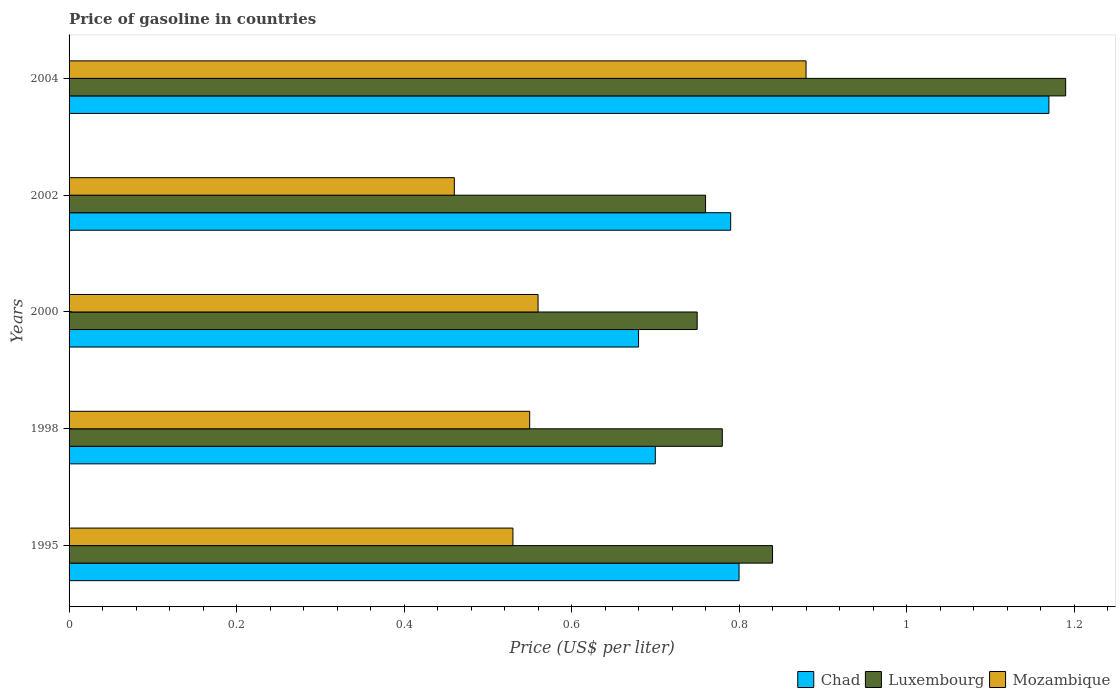Are the number of bars per tick equal to the number of legend labels?
Your response must be concise. Yes. Are the number of bars on each tick of the Y-axis equal?
Provide a succinct answer. Yes. How many bars are there on the 4th tick from the top?
Ensure brevity in your answer.  3. What is the label of the 3rd group of bars from the top?
Your response must be concise. 2000. In how many cases, is the number of bars for a given year not equal to the number of legend labels?
Keep it short and to the point. 0. Across all years, what is the maximum price of gasoline in Luxembourg?
Your answer should be compact. 1.19. Across all years, what is the minimum price of gasoline in Mozambique?
Your answer should be very brief. 0.46. What is the total price of gasoline in Chad in the graph?
Ensure brevity in your answer.  4.14. What is the difference between the price of gasoline in Luxembourg in 1998 and that in 2004?
Offer a terse response. -0.41. What is the difference between the price of gasoline in Mozambique in 1998 and the price of gasoline in Chad in 1995?
Keep it short and to the point. -0.25. What is the average price of gasoline in Luxembourg per year?
Your answer should be compact. 0.86. In the year 1995, what is the difference between the price of gasoline in Luxembourg and price of gasoline in Chad?
Your response must be concise. 0.04. In how many years, is the price of gasoline in Luxembourg greater than 0.52 US$?
Ensure brevity in your answer.  5. What is the ratio of the price of gasoline in Mozambique in 2002 to that in 2004?
Keep it short and to the point. 0.52. Is the price of gasoline in Luxembourg in 1998 less than that in 2004?
Give a very brief answer. Yes. What is the difference between the highest and the second highest price of gasoline in Luxembourg?
Your answer should be compact. 0.35. What is the difference between the highest and the lowest price of gasoline in Luxembourg?
Make the answer very short. 0.44. What does the 1st bar from the top in 1998 represents?
Offer a very short reply. Mozambique. What does the 1st bar from the bottom in 1998 represents?
Offer a terse response. Chad. Is it the case that in every year, the sum of the price of gasoline in Chad and price of gasoline in Luxembourg is greater than the price of gasoline in Mozambique?
Your answer should be compact. Yes. How many years are there in the graph?
Give a very brief answer. 5. What is the difference between two consecutive major ticks on the X-axis?
Your response must be concise. 0.2. How many legend labels are there?
Provide a short and direct response. 3. How are the legend labels stacked?
Your response must be concise. Horizontal. What is the title of the graph?
Provide a succinct answer. Price of gasoline in countries. Does "Low income" appear as one of the legend labels in the graph?
Your response must be concise. No. What is the label or title of the X-axis?
Keep it short and to the point. Price (US$ per liter). What is the label or title of the Y-axis?
Provide a short and direct response. Years. What is the Price (US$ per liter) of Chad in 1995?
Make the answer very short. 0.8. What is the Price (US$ per liter) in Luxembourg in 1995?
Make the answer very short. 0.84. What is the Price (US$ per liter) of Mozambique in 1995?
Your answer should be very brief. 0.53. What is the Price (US$ per liter) of Chad in 1998?
Offer a very short reply. 0.7. What is the Price (US$ per liter) in Luxembourg in 1998?
Provide a succinct answer. 0.78. What is the Price (US$ per liter) in Mozambique in 1998?
Your response must be concise. 0.55. What is the Price (US$ per liter) of Chad in 2000?
Your answer should be very brief. 0.68. What is the Price (US$ per liter) of Mozambique in 2000?
Provide a succinct answer. 0.56. What is the Price (US$ per liter) in Chad in 2002?
Offer a very short reply. 0.79. What is the Price (US$ per liter) in Luxembourg in 2002?
Your answer should be compact. 0.76. What is the Price (US$ per liter) of Mozambique in 2002?
Offer a terse response. 0.46. What is the Price (US$ per liter) of Chad in 2004?
Make the answer very short. 1.17. What is the Price (US$ per liter) in Luxembourg in 2004?
Provide a short and direct response. 1.19. Across all years, what is the maximum Price (US$ per liter) of Chad?
Provide a short and direct response. 1.17. Across all years, what is the maximum Price (US$ per liter) in Luxembourg?
Ensure brevity in your answer.  1.19. Across all years, what is the minimum Price (US$ per liter) in Chad?
Offer a terse response. 0.68. Across all years, what is the minimum Price (US$ per liter) of Mozambique?
Offer a very short reply. 0.46. What is the total Price (US$ per liter) in Chad in the graph?
Your response must be concise. 4.14. What is the total Price (US$ per liter) of Luxembourg in the graph?
Your answer should be very brief. 4.32. What is the total Price (US$ per liter) in Mozambique in the graph?
Provide a succinct answer. 2.98. What is the difference between the Price (US$ per liter) of Chad in 1995 and that in 1998?
Your answer should be compact. 0.1. What is the difference between the Price (US$ per liter) in Luxembourg in 1995 and that in 1998?
Keep it short and to the point. 0.06. What is the difference between the Price (US$ per liter) of Mozambique in 1995 and that in 1998?
Make the answer very short. -0.02. What is the difference between the Price (US$ per liter) in Chad in 1995 and that in 2000?
Your response must be concise. 0.12. What is the difference between the Price (US$ per liter) of Luxembourg in 1995 and that in 2000?
Your response must be concise. 0.09. What is the difference between the Price (US$ per liter) of Mozambique in 1995 and that in 2000?
Your response must be concise. -0.03. What is the difference between the Price (US$ per liter) in Chad in 1995 and that in 2002?
Provide a succinct answer. 0.01. What is the difference between the Price (US$ per liter) of Mozambique in 1995 and that in 2002?
Give a very brief answer. 0.07. What is the difference between the Price (US$ per liter) in Chad in 1995 and that in 2004?
Provide a short and direct response. -0.37. What is the difference between the Price (US$ per liter) of Luxembourg in 1995 and that in 2004?
Ensure brevity in your answer.  -0.35. What is the difference between the Price (US$ per liter) in Mozambique in 1995 and that in 2004?
Ensure brevity in your answer.  -0.35. What is the difference between the Price (US$ per liter) in Luxembourg in 1998 and that in 2000?
Provide a short and direct response. 0.03. What is the difference between the Price (US$ per liter) of Mozambique in 1998 and that in 2000?
Your answer should be very brief. -0.01. What is the difference between the Price (US$ per liter) of Chad in 1998 and that in 2002?
Offer a terse response. -0.09. What is the difference between the Price (US$ per liter) in Mozambique in 1998 and that in 2002?
Give a very brief answer. 0.09. What is the difference between the Price (US$ per liter) of Chad in 1998 and that in 2004?
Offer a very short reply. -0.47. What is the difference between the Price (US$ per liter) of Luxembourg in 1998 and that in 2004?
Keep it short and to the point. -0.41. What is the difference between the Price (US$ per liter) of Mozambique in 1998 and that in 2004?
Your answer should be very brief. -0.33. What is the difference between the Price (US$ per liter) of Chad in 2000 and that in 2002?
Offer a terse response. -0.11. What is the difference between the Price (US$ per liter) in Luxembourg in 2000 and that in 2002?
Make the answer very short. -0.01. What is the difference between the Price (US$ per liter) in Mozambique in 2000 and that in 2002?
Give a very brief answer. 0.1. What is the difference between the Price (US$ per liter) of Chad in 2000 and that in 2004?
Offer a very short reply. -0.49. What is the difference between the Price (US$ per liter) in Luxembourg in 2000 and that in 2004?
Provide a short and direct response. -0.44. What is the difference between the Price (US$ per liter) in Mozambique in 2000 and that in 2004?
Keep it short and to the point. -0.32. What is the difference between the Price (US$ per liter) in Chad in 2002 and that in 2004?
Ensure brevity in your answer.  -0.38. What is the difference between the Price (US$ per liter) in Luxembourg in 2002 and that in 2004?
Provide a succinct answer. -0.43. What is the difference between the Price (US$ per liter) of Mozambique in 2002 and that in 2004?
Ensure brevity in your answer.  -0.42. What is the difference between the Price (US$ per liter) in Chad in 1995 and the Price (US$ per liter) in Mozambique in 1998?
Give a very brief answer. 0.25. What is the difference between the Price (US$ per liter) in Luxembourg in 1995 and the Price (US$ per liter) in Mozambique in 1998?
Your answer should be very brief. 0.29. What is the difference between the Price (US$ per liter) of Chad in 1995 and the Price (US$ per liter) of Luxembourg in 2000?
Give a very brief answer. 0.05. What is the difference between the Price (US$ per liter) in Chad in 1995 and the Price (US$ per liter) in Mozambique in 2000?
Provide a succinct answer. 0.24. What is the difference between the Price (US$ per liter) in Luxembourg in 1995 and the Price (US$ per liter) in Mozambique in 2000?
Your response must be concise. 0.28. What is the difference between the Price (US$ per liter) of Chad in 1995 and the Price (US$ per liter) of Mozambique in 2002?
Keep it short and to the point. 0.34. What is the difference between the Price (US$ per liter) of Luxembourg in 1995 and the Price (US$ per liter) of Mozambique in 2002?
Make the answer very short. 0.38. What is the difference between the Price (US$ per liter) of Chad in 1995 and the Price (US$ per liter) of Luxembourg in 2004?
Offer a terse response. -0.39. What is the difference between the Price (US$ per liter) of Chad in 1995 and the Price (US$ per liter) of Mozambique in 2004?
Keep it short and to the point. -0.08. What is the difference between the Price (US$ per liter) in Luxembourg in 1995 and the Price (US$ per liter) in Mozambique in 2004?
Make the answer very short. -0.04. What is the difference between the Price (US$ per liter) in Chad in 1998 and the Price (US$ per liter) in Luxembourg in 2000?
Offer a terse response. -0.05. What is the difference between the Price (US$ per liter) of Chad in 1998 and the Price (US$ per liter) of Mozambique in 2000?
Keep it short and to the point. 0.14. What is the difference between the Price (US$ per liter) in Luxembourg in 1998 and the Price (US$ per liter) in Mozambique in 2000?
Make the answer very short. 0.22. What is the difference between the Price (US$ per liter) of Chad in 1998 and the Price (US$ per liter) of Luxembourg in 2002?
Your answer should be compact. -0.06. What is the difference between the Price (US$ per liter) of Chad in 1998 and the Price (US$ per liter) of Mozambique in 2002?
Your response must be concise. 0.24. What is the difference between the Price (US$ per liter) in Luxembourg in 1998 and the Price (US$ per liter) in Mozambique in 2002?
Offer a very short reply. 0.32. What is the difference between the Price (US$ per liter) in Chad in 1998 and the Price (US$ per liter) in Luxembourg in 2004?
Provide a short and direct response. -0.49. What is the difference between the Price (US$ per liter) in Chad in 1998 and the Price (US$ per liter) in Mozambique in 2004?
Ensure brevity in your answer.  -0.18. What is the difference between the Price (US$ per liter) in Chad in 2000 and the Price (US$ per liter) in Luxembourg in 2002?
Provide a short and direct response. -0.08. What is the difference between the Price (US$ per liter) of Chad in 2000 and the Price (US$ per liter) of Mozambique in 2002?
Give a very brief answer. 0.22. What is the difference between the Price (US$ per liter) of Luxembourg in 2000 and the Price (US$ per liter) of Mozambique in 2002?
Ensure brevity in your answer.  0.29. What is the difference between the Price (US$ per liter) of Chad in 2000 and the Price (US$ per liter) of Luxembourg in 2004?
Ensure brevity in your answer.  -0.51. What is the difference between the Price (US$ per liter) in Luxembourg in 2000 and the Price (US$ per liter) in Mozambique in 2004?
Keep it short and to the point. -0.13. What is the difference between the Price (US$ per liter) in Chad in 2002 and the Price (US$ per liter) in Mozambique in 2004?
Make the answer very short. -0.09. What is the difference between the Price (US$ per liter) in Luxembourg in 2002 and the Price (US$ per liter) in Mozambique in 2004?
Offer a terse response. -0.12. What is the average Price (US$ per liter) in Chad per year?
Your answer should be compact. 0.83. What is the average Price (US$ per liter) in Luxembourg per year?
Your answer should be very brief. 0.86. What is the average Price (US$ per liter) in Mozambique per year?
Offer a terse response. 0.6. In the year 1995, what is the difference between the Price (US$ per liter) of Chad and Price (US$ per liter) of Luxembourg?
Give a very brief answer. -0.04. In the year 1995, what is the difference between the Price (US$ per liter) in Chad and Price (US$ per liter) in Mozambique?
Offer a terse response. 0.27. In the year 1995, what is the difference between the Price (US$ per liter) in Luxembourg and Price (US$ per liter) in Mozambique?
Keep it short and to the point. 0.31. In the year 1998, what is the difference between the Price (US$ per liter) of Chad and Price (US$ per liter) of Luxembourg?
Your answer should be very brief. -0.08. In the year 1998, what is the difference between the Price (US$ per liter) of Chad and Price (US$ per liter) of Mozambique?
Your response must be concise. 0.15. In the year 1998, what is the difference between the Price (US$ per liter) in Luxembourg and Price (US$ per liter) in Mozambique?
Offer a terse response. 0.23. In the year 2000, what is the difference between the Price (US$ per liter) of Chad and Price (US$ per liter) of Luxembourg?
Your answer should be compact. -0.07. In the year 2000, what is the difference between the Price (US$ per liter) in Chad and Price (US$ per liter) in Mozambique?
Ensure brevity in your answer.  0.12. In the year 2000, what is the difference between the Price (US$ per liter) of Luxembourg and Price (US$ per liter) of Mozambique?
Your answer should be very brief. 0.19. In the year 2002, what is the difference between the Price (US$ per liter) of Chad and Price (US$ per liter) of Mozambique?
Give a very brief answer. 0.33. In the year 2002, what is the difference between the Price (US$ per liter) of Luxembourg and Price (US$ per liter) of Mozambique?
Give a very brief answer. 0.3. In the year 2004, what is the difference between the Price (US$ per liter) of Chad and Price (US$ per liter) of Luxembourg?
Make the answer very short. -0.02. In the year 2004, what is the difference between the Price (US$ per liter) in Chad and Price (US$ per liter) in Mozambique?
Make the answer very short. 0.29. In the year 2004, what is the difference between the Price (US$ per liter) of Luxembourg and Price (US$ per liter) of Mozambique?
Ensure brevity in your answer.  0.31. What is the ratio of the Price (US$ per liter) of Mozambique in 1995 to that in 1998?
Your response must be concise. 0.96. What is the ratio of the Price (US$ per liter) in Chad in 1995 to that in 2000?
Your answer should be very brief. 1.18. What is the ratio of the Price (US$ per liter) of Luxembourg in 1995 to that in 2000?
Offer a very short reply. 1.12. What is the ratio of the Price (US$ per liter) of Mozambique in 1995 to that in 2000?
Provide a short and direct response. 0.95. What is the ratio of the Price (US$ per liter) in Chad in 1995 to that in 2002?
Your answer should be compact. 1.01. What is the ratio of the Price (US$ per liter) in Luxembourg in 1995 to that in 2002?
Your answer should be compact. 1.11. What is the ratio of the Price (US$ per liter) in Mozambique in 1995 to that in 2002?
Make the answer very short. 1.15. What is the ratio of the Price (US$ per liter) in Chad in 1995 to that in 2004?
Ensure brevity in your answer.  0.68. What is the ratio of the Price (US$ per liter) of Luxembourg in 1995 to that in 2004?
Provide a short and direct response. 0.71. What is the ratio of the Price (US$ per liter) of Mozambique in 1995 to that in 2004?
Offer a very short reply. 0.6. What is the ratio of the Price (US$ per liter) of Chad in 1998 to that in 2000?
Provide a short and direct response. 1.03. What is the ratio of the Price (US$ per liter) in Mozambique in 1998 to that in 2000?
Your response must be concise. 0.98. What is the ratio of the Price (US$ per liter) in Chad in 1998 to that in 2002?
Provide a short and direct response. 0.89. What is the ratio of the Price (US$ per liter) in Luxembourg in 1998 to that in 2002?
Make the answer very short. 1.03. What is the ratio of the Price (US$ per liter) of Mozambique in 1998 to that in 2002?
Make the answer very short. 1.2. What is the ratio of the Price (US$ per liter) in Chad in 1998 to that in 2004?
Your answer should be compact. 0.6. What is the ratio of the Price (US$ per liter) of Luxembourg in 1998 to that in 2004?
Your response must be concise. 0.66. What is the ratio of the Price (US$ per liter) of Chad in 2000 to that in 2002?
Keep it short and to the point. 0.86. What is the ratio of the Price (US$ per liter) in Mozambique in 2000 to that in 2002?
Your response must be concise. 1.22. What is the ratio of the Price (US$ per liter) of Chad in 2000 to that in 2004?
Give a very brief answer. 0.58. What is the ratio of the Price (US$ per liter) in Luxembourg in 2000 to that in 2004?
Provide a succinct answer. 0.63. What is the ratio of the Price (US$ per liter) of Mozambique in 2000 to that in 2004?
Keep it short and to the point. 0.64. What is the ratio of the Price (US$ per liter) of Chad in 2002 to that in 2004?
Your answer should be compact. 0.68. What is the ratio of the Price (US$ per liter) in Luxembourg in 2002 to that in 2004?
Keep it short and to the point. 0.64. What is the ratio of the Price (US$ per liter) of Mozambique in 2002 to that in 2004?
Your answer should be compact. 0.52. What is the difference between the highest and the second highest Price (US$ per liter) in Chad?
Offer a very short reply. 0.37. What is the difference between the highest and the second highest Price (US$ per liter) in Luxembourg?
Provide a short and direct response. 0.35. What is the difference between the highest and the second highest Price (US$ per liter) in Mozambique?
Provide a short and direct response. 0.32. What is the difference between the highest and the lowest Price (US$ per liter) of Chad?
Your answer should be compact. 0.49. What is the difference between the highest and the lowest Price (US$ per liter) in Luxembourg?
Your answer should be very brief. 0.44. What is the difference between the highest and the lowest Price (US$ per liter) of Mozambique?
Your answer should be very brief. 0.42. 